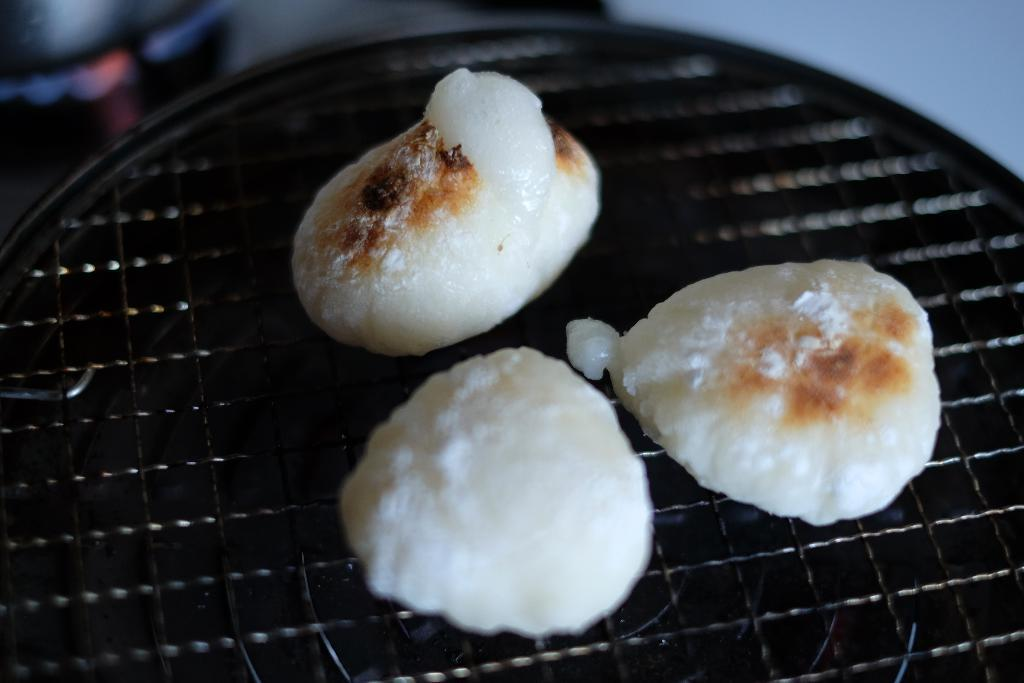What is being cooked in the image? There is food on a grill in the image. Can you describe the background of the image? The background of the image is blurry. How many chickens are present in the image? There are no chickens present in the image. What scientific theory is being discussed in the image? There is no discussion of a scientific theory in the image. 